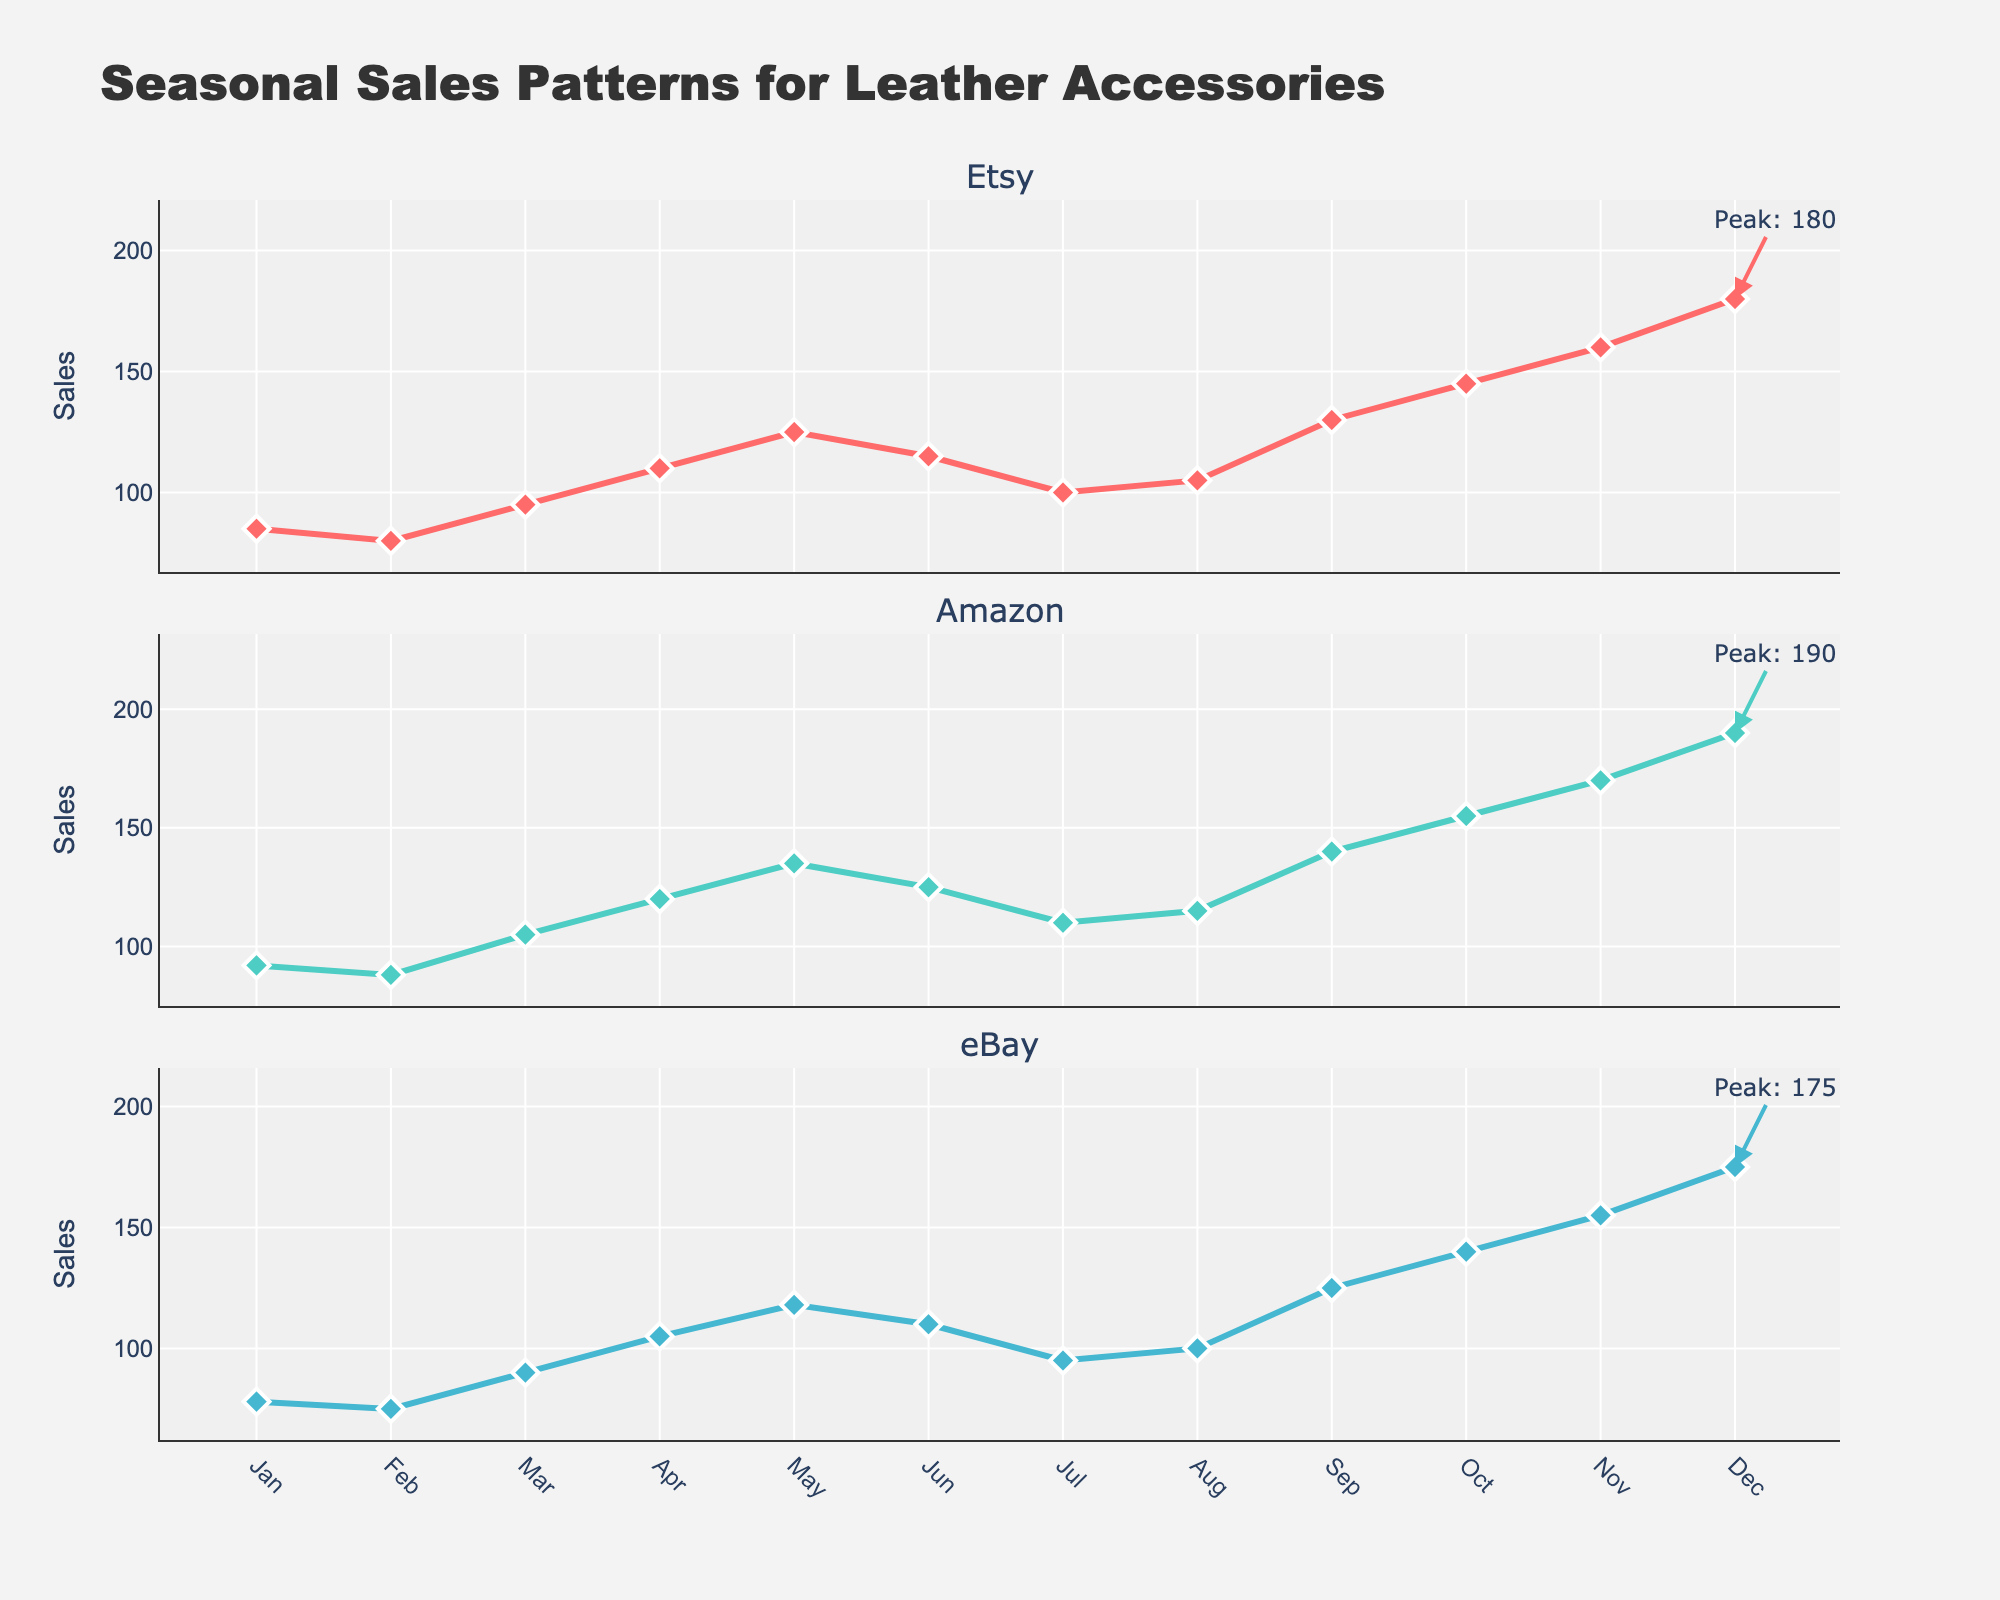what is the title of the figure? The title is usually at the top of the figure and can be easily read. Here, it is placed prominently in the center
Answer: Seasonal Sales Patterns for Leather Accessories what is the color used for Amazon? The figure uses a custom color palette. The color for Amazon is identified based on the chart's legend or the color visible in the Amazon subplot
Answer: Teal which month shows the peak sales for Etsy? The highest point on the Etsy subplot indicates the peak sales, with an annotation pointing out the month.
Answer: December what is the lowest sales value recorded in eBay and in which month? By identifying the lowest point in the eBay subplot, marked by the lowest data value and its corresponding month.
Answer: February, 75 which platform shows the highest overall peak sales? The highest peak is determined by comparing the maximum sales values annotated in each subplot.
Answer: Amazon how many subplots are in the figure? Each major online marketplace has its own subplot, vertically stacked. Count these.
Answer: 3 In which month do Etsy and Amazon both show a sales dip compared to their previous month? Compare the sales values month-over-month and find when both Etsy and Amazon show a decrease.
Answer: July how many data points are shown per marketplace? Count the number of months listed on the x-axis, which corresponds to the number of data points per subplot.
Answer: 12 what is the total sales in December across all three platforms? Sum the sales values in December for Etsy, Amazon, and eBay.
Answer: 545 which platform has the highest average sales over the year? Calculate the average sales for each platform and compare them.
Answer: Amazon 